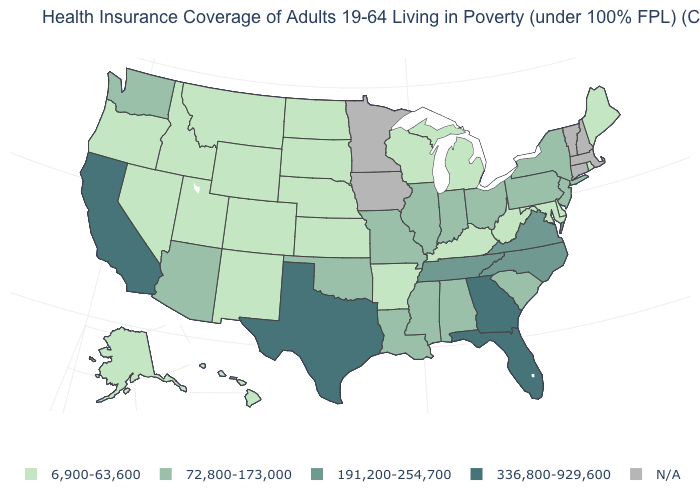What is the value of New Jersey?
Short answer required. 72,800-173,000. Is the legend a continuous bar?
Answer briefly. No. Does the map have missing data?
Short answer required. Yes. What is the value of Rhode Island?
Concise answer only. 6,900-63,600. What is the lowest value in the USA?
Short answer required. 6,900-63,600. Name the states that have a value in the range 336,800-929,600?
Keep it brief. California, Florida, Georgia, Texas. Does Georgia have the highest value in the USA?
Short answer required. Yes. Does Pennsylvania have the lowest value in the Northeast?
Short answer required. No. Name the states that have a value in the range N/A?
Short answer required. Connecticut, Iowa, Massachusetts, Minnesota, New Hampshire, Vermont. Which states have the highest value in the USA?
Answer briefly. California, Florida, Georgia, Texas. What is the highest value in the Northeast ?
Keep it brief. 72,800-173,000. What is the lowest value in the USA?
Quick response, please. 6,900-63,600. Which states have the highest value in the USA?
Concise answer only. California, Florida, Georgia, Texas. Does California have the lowest value in the USA?
Be succinct. No. What is the value of Delaware?
Answer briefly. 6,900-63,600. 